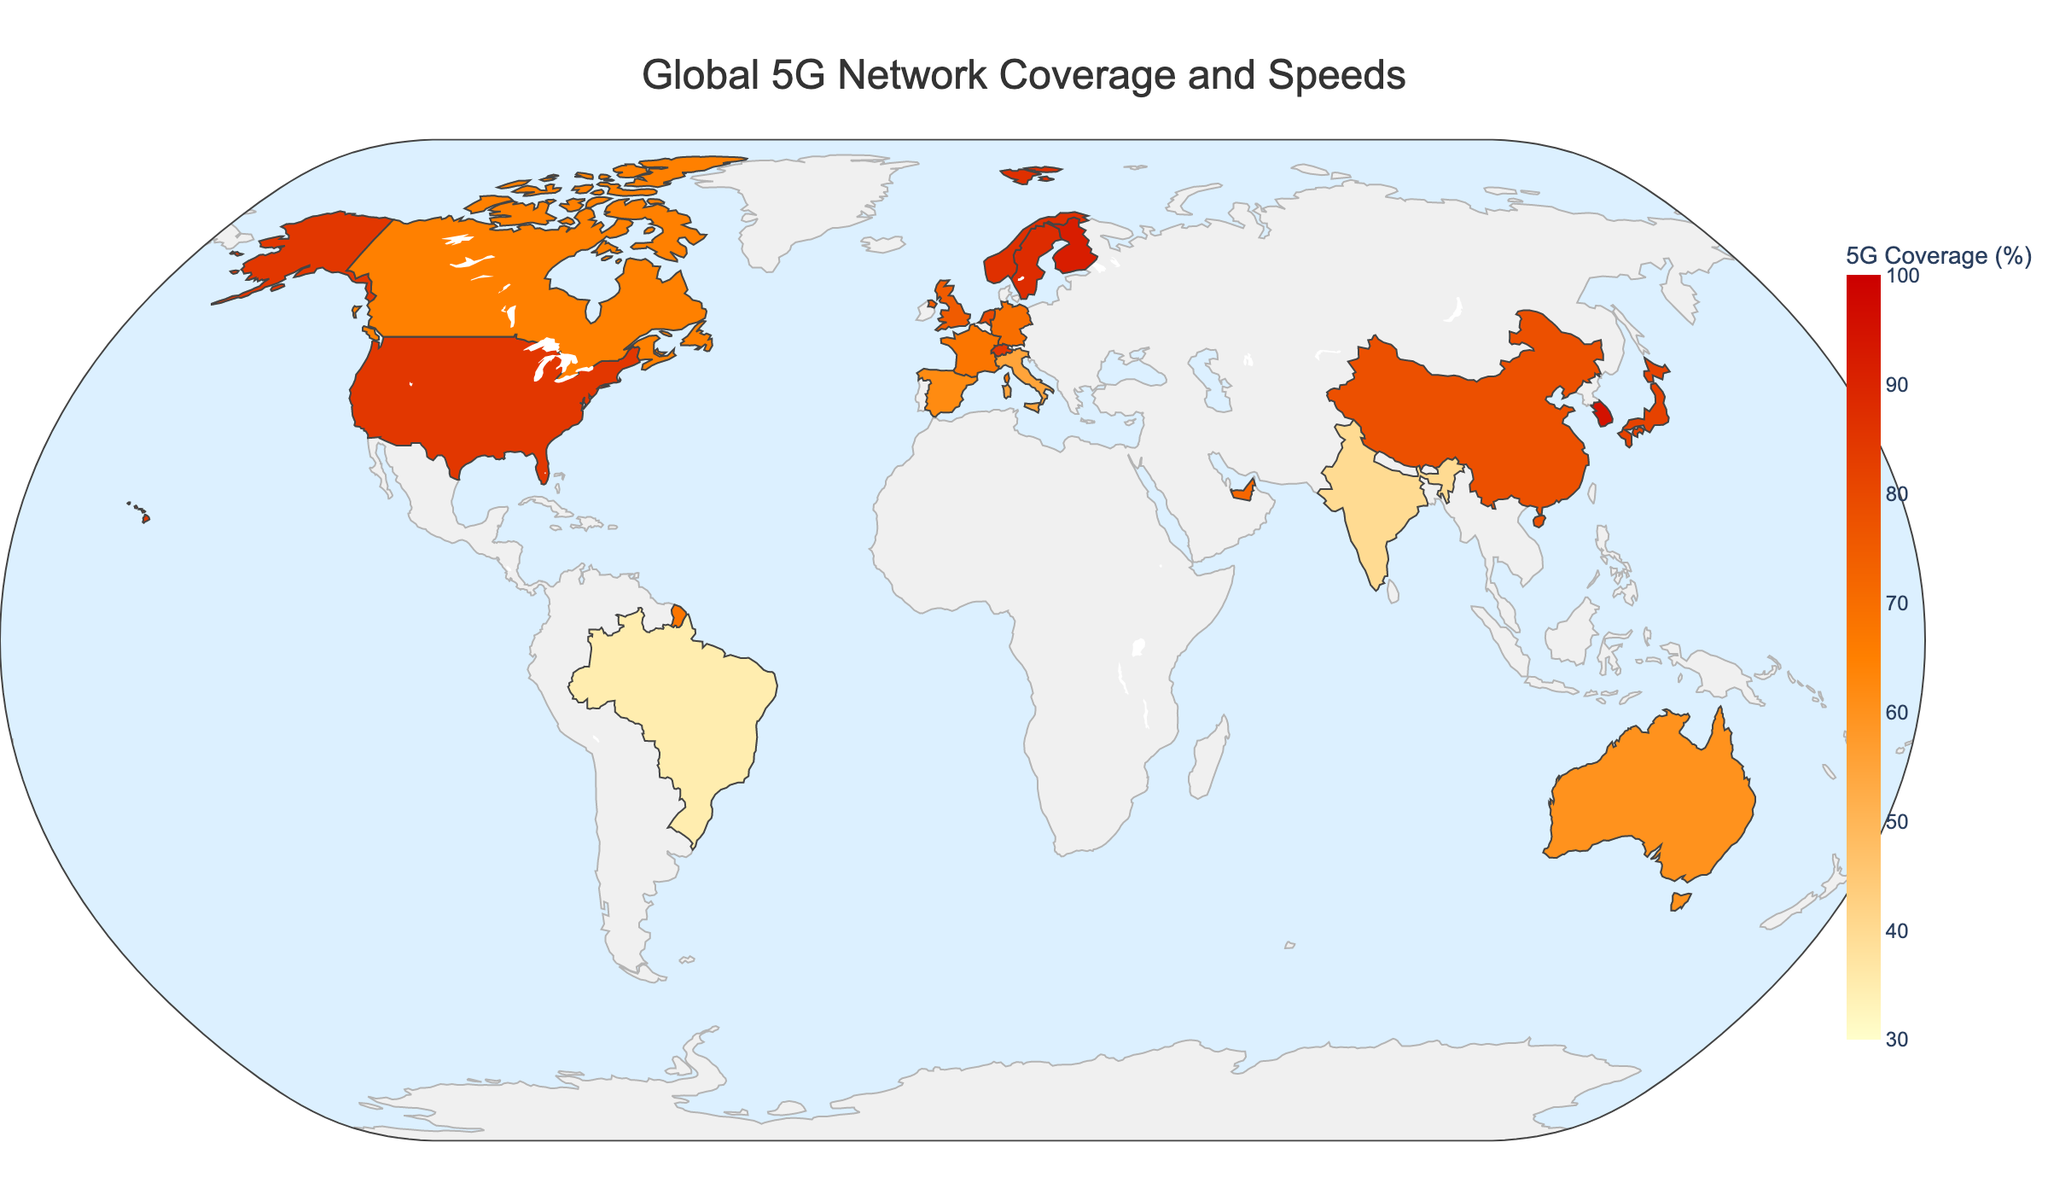What is the country with the highest 5G coverage percentage? The figure shows 5G coverage percentages for various countries. South Korea has the highest coverage with 95%.
Answer: South Korea Which country has the fastest average 5G speed? The figure shows average 5G speeds for various countries. South Korea has the fastest average speed at 450 Mbps.
Answer: South Korea Between Germany and the United Kingdom, which country has a higher 5G coverage percentage? The 5G coverage percentage for Germany is 70%, while for the United Kingdom it is 75%. Therefore, the United Kingdom has a higher percentage.
Answer: United Kingdom What is the difference in 5G coverage percentage between the country with the highest and the country with the lowest coverage? The highest coverage is in South Korea (95%) and the lowest is in Brazil (35%). The difference is 95% - 35% = 60%.
Answer: 60% Which country has a faster average 5G speed, Canada or France? The average 5G speed in Canada is 180 Mbps, while in France it is 240 Mbps. Thus, France has a faster speed.
Answer: France What is the combined 5G coverage percentage for Japan and Switzerland? The 5G coverage percentage for Japan is 82%, and for Switzerland, it is 85%. The combined coverage is 82% + 85% = 167%.
Answer: 167% Which countries have an average 5G speed above 400 Mbps? According to the figure, the countries with average 5G speeds above 400 Mbps are South Korea (450 Mbps), Singapore (420 Mbps), Finland (430 Mbps), and Sweden (400 Mbps).
Answer: South Korea, Singapore, Finland, Sweden How much more 5G coverage does the United Arab Emirates have compared to Italy? The 5G coverage in the United Arab Emirates is 72%, while in Italy it is 55%. The difference is 72% - 55% = 17%.
Answer: 17% Among countries with 5G coverage above 80%, which has the lowest average 5G speed? From the figure, the countries with 5G coverage above 80% are United States, South Korea, Japan, Sweden, Singapore, Switzerland, Finland, and Norway. Among these, the United States has the lowest average speed of 250 Mbps.
Answer: United States 